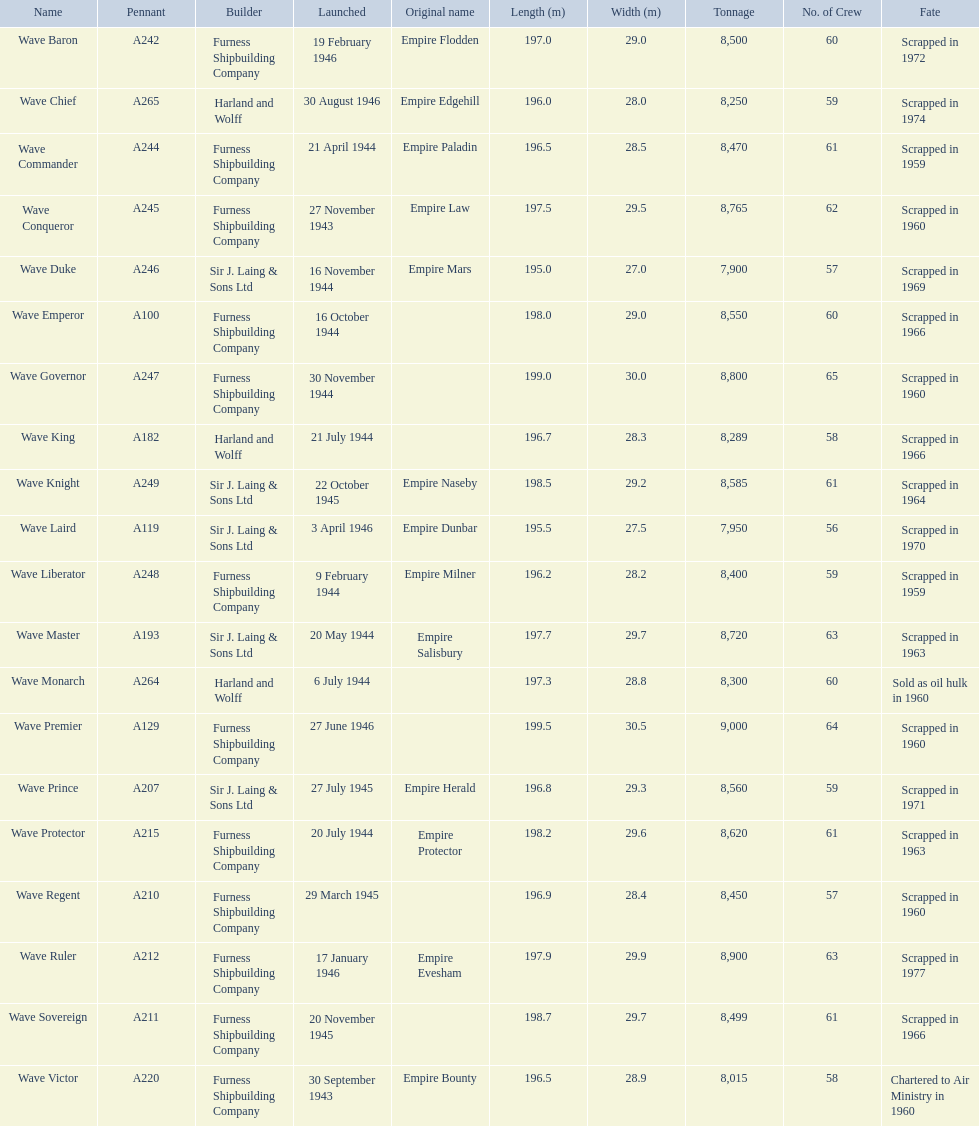What builders launched ships in november of any year? Furness Shipbuilding Company, Sir J. Laing & Sons Ltd, Furness Shipbuilding Company, Furness Shipbuilding Company. What ship builders ships had their original name's changed prior to scrapping? Furness Shipbuilding Company, Sir J. Laing & Sons Ltd. What was the name of the ship that was built in november and had its name changed prior to scrapping only 12 years after its launch? Wave Conqueror. 